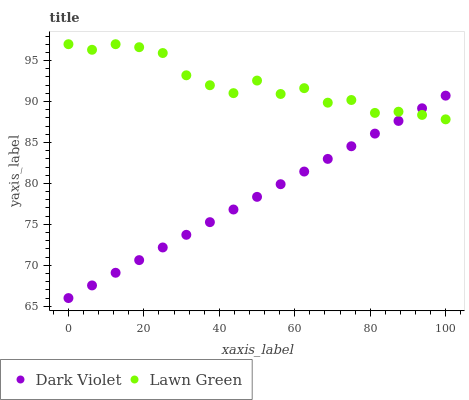Does Dark Violet have the minimum area under the curve?
Answer yes or no. Yes. Does Lawn Green have the maximum area under the curve?
Answer yes or no. Yes. Does Dark Violet have the maximum area under the curve?
Answer yes or no. No. Is Dark Violet the smoothest?
Answer yes or no. Yes. Is Lawn Green the roughest?
Answer yes or no. Yes. Is Dark Violet the roughest?
Answer yes or no. No. Does Dark Violet have the lowest value?
Answer yes or no. Yes. Does Lawn Green have the highest value?
Answer yes or no. Yes. Does Dark Violet have the highest value?
Answer yes or no. No. Does Lawn Green intersect Dark Violet?
Answer yes or no. Yes. Is Lawn Green less than Dark Violet?
Answer yes or no. No. Is Lawn Green greater than Dark Violet?
Answer yes or no. No. 